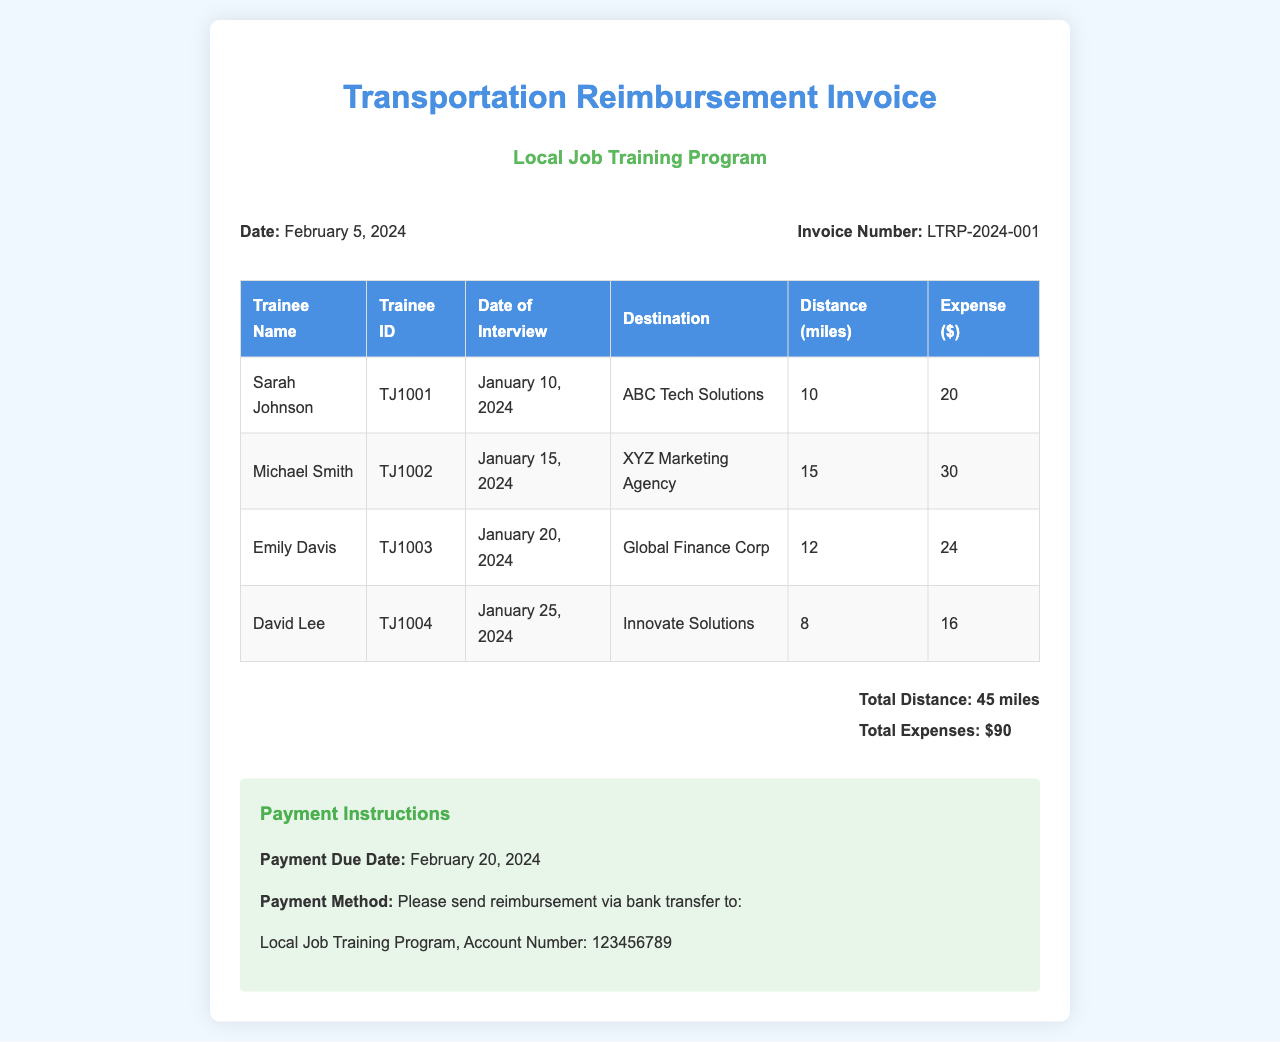What is the date of the invoice? The date of the invoice is stated in the document as February 5, 2024.
Answer: February 5, 2024 What is the invoice number? The invoice number is found in the document and is LTRP-2024-001.
Answer: LTRP-2024-001 Who is the trainee with ID TJ1003? The document lists the trainee names along with their IDs, and TJ1003 corresponds to Emily Davis.
Answer: Emily Davis What was the expense for Michael Smith? The expense amount for Michael Smith is detailed in the table in the document as $30.
Answer: $30 What is the total distance traveled by the trainees? The total distance is summed up in the summary section of the document, which states 45 miles.
Answer: 45 miles What payment method is specified in the document? The document specifies that reimbursement should be sent via bank transfer.
Answer: Bank transfer On what date was David Lee's interview? The document provides a specific date for David Lee's interview, which is January 25, 2024.
Answer: January 25, 2024 What is the payment due date? The payment due date is mentioned clearly in the payment instructions as February 20, 2024.
Answer: February 20, 2024 How much are the total expenses for all trainees? The summary section lists the total expenses as $90.
Answer: $90 